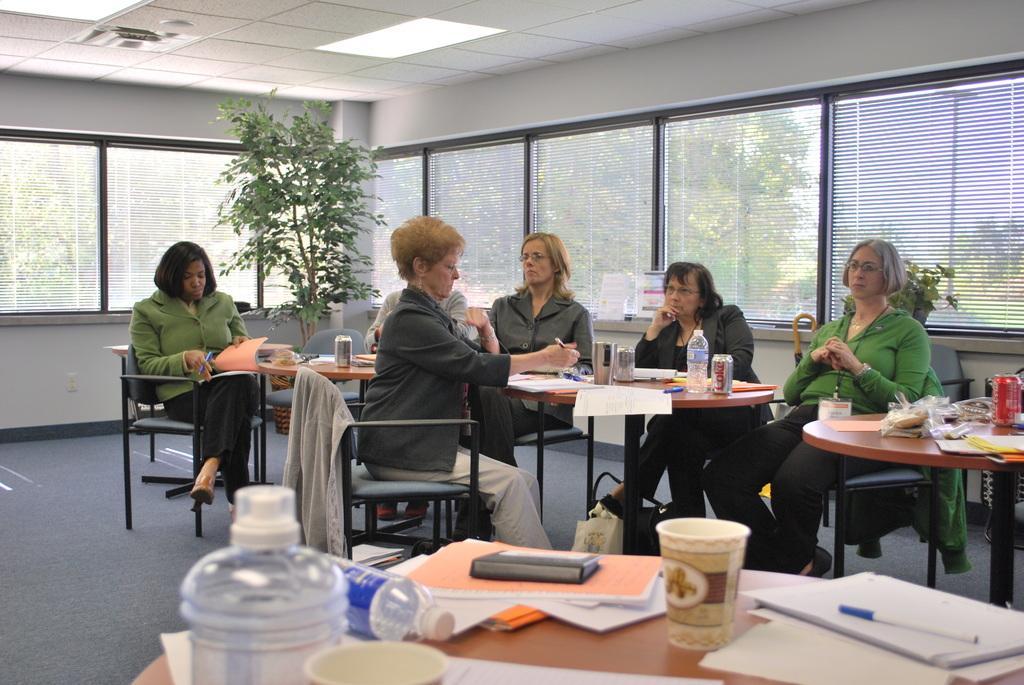Describe this image in one or two sentences. An indoor picture. This persons are sitting on a chair. In-front of this person's there is a table, on a table there is a bottle, tin, papers, book and pen. On this chair there is a jacket. This woman is holding a book and pen. This is a plant. Outside of the windows there are trees. 